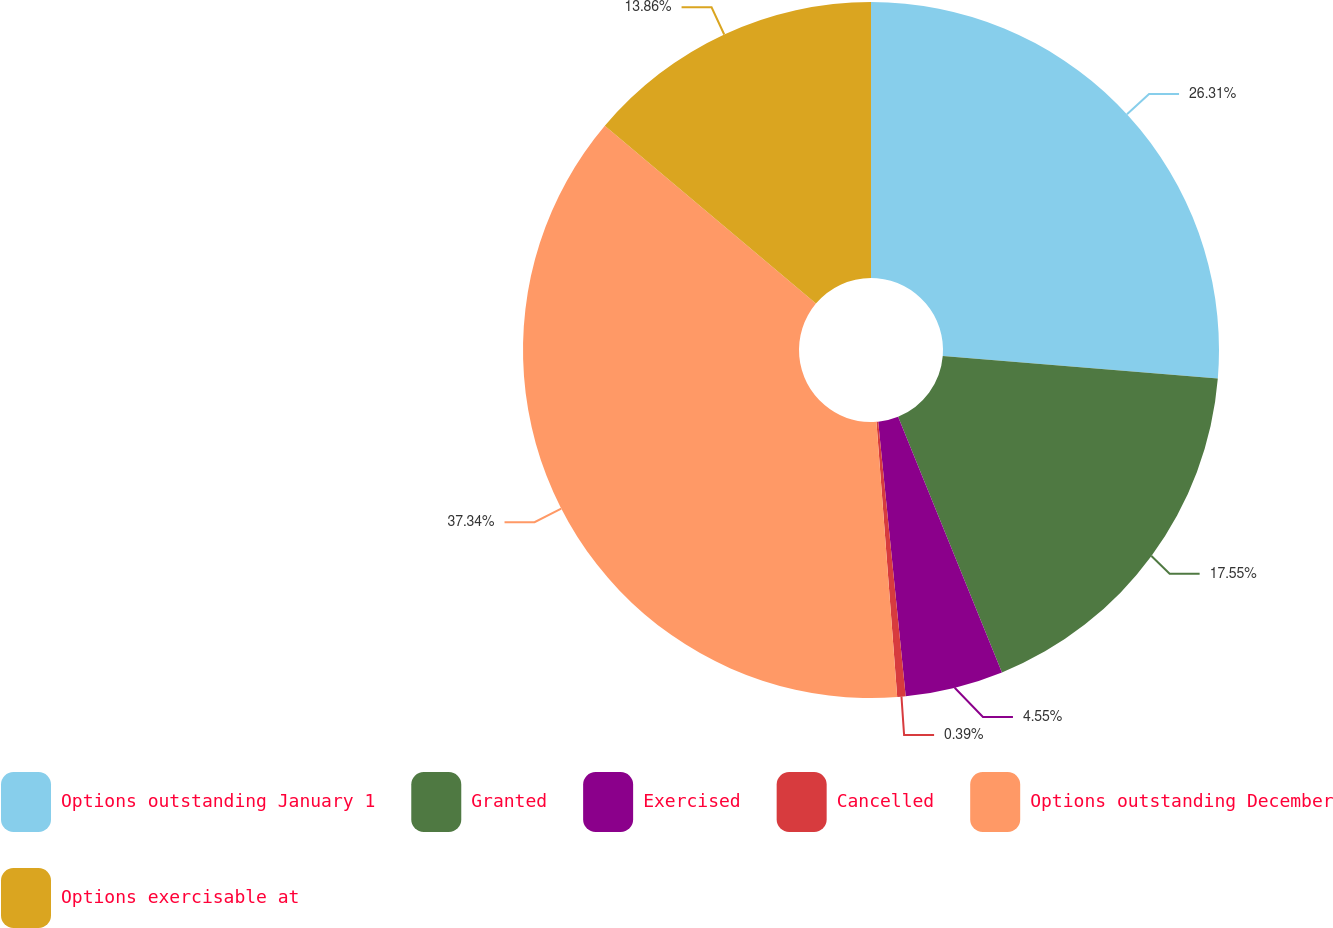Convert chart to OTSL. <chart><loc_0><loc_0><loc_500><loc_500><pie_chart><fcel>Options outstanding January 1<fcel>Granted<fcel>Exercised<fcel>Cancelled<fcel>Options outstanding December<fcel>Options exercisable at<nl><fcel>26.31%<fcel>17.55%<fcel>4.55%<fcel>0.39%<fcel>37.34%<fcel>13.86%<nl></chart> 